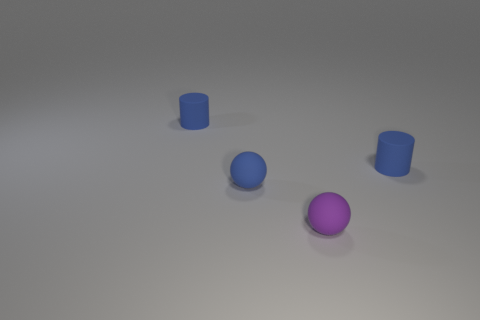There is a ball that is the same size as the purple object; what is it made of?
Offer a terse response. Rubber. Do the blue sphere and the small purple thing have the same material?
Keep it short and to the point. Yes. What number of things are purple things or tiny cylinders?
Provide a succinct answer. 3. What shape is the blue matte object to the right of the tiny blue sphere?
Make the answer very short. Cylinder. What color is the other tiny sphere that is made of the same material as the small purple sphere?
Provide a succinct answer. Blue. What is the material of the tiny blue thing that is the same shape as the purple object?
Your answer should be compact. Rubber. The small purple rubber thing is what shape?
Provide a short and direct response. Sphere. There is a small thing that is both behind the blue ball and to the right of the blue matte sphere; what material is it?
Offer a terse response. Rubber. The purple object that is made of the same material as the blue sphere is what shape?
Offer a very short reply. Sphere. What is the shape of the thing that is both behind the tiny blue sphere and left of the tiny purple matte ball?
Keep it short and to the point. Cylinder. 